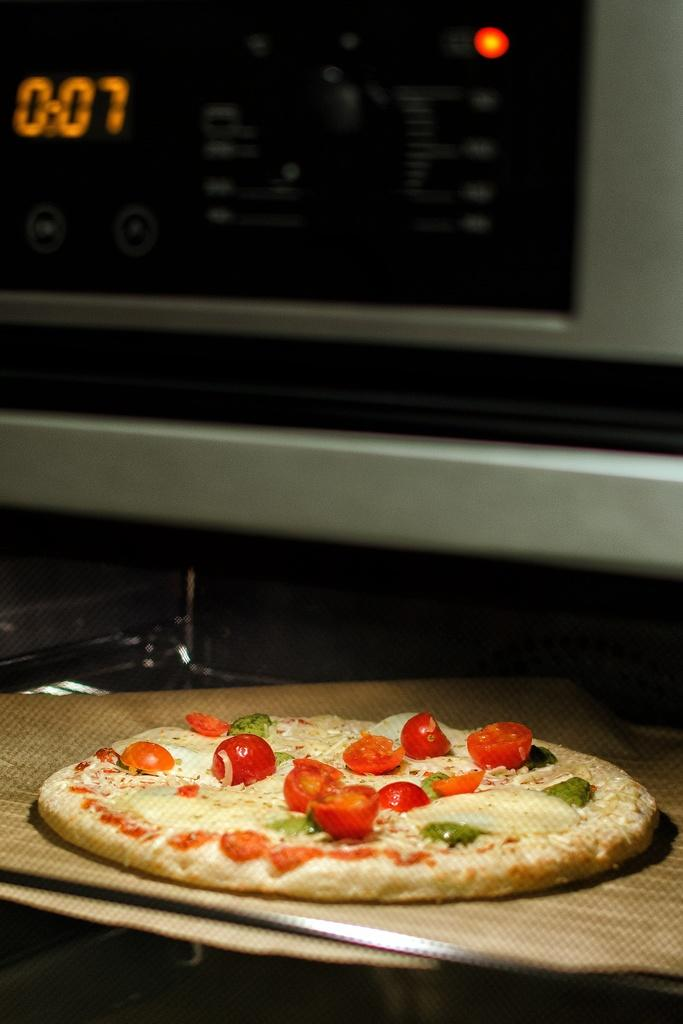What type of food is visible in the image? There is a pizza in the image. Where is the pizza located? The pizza is on a surface in the image. What other object can be seen at the top of the image? There is a microphone at the top of the image. What advice do the birds give to the boys in the image? There are no birds or boys present in the image, so no advice can be given. 